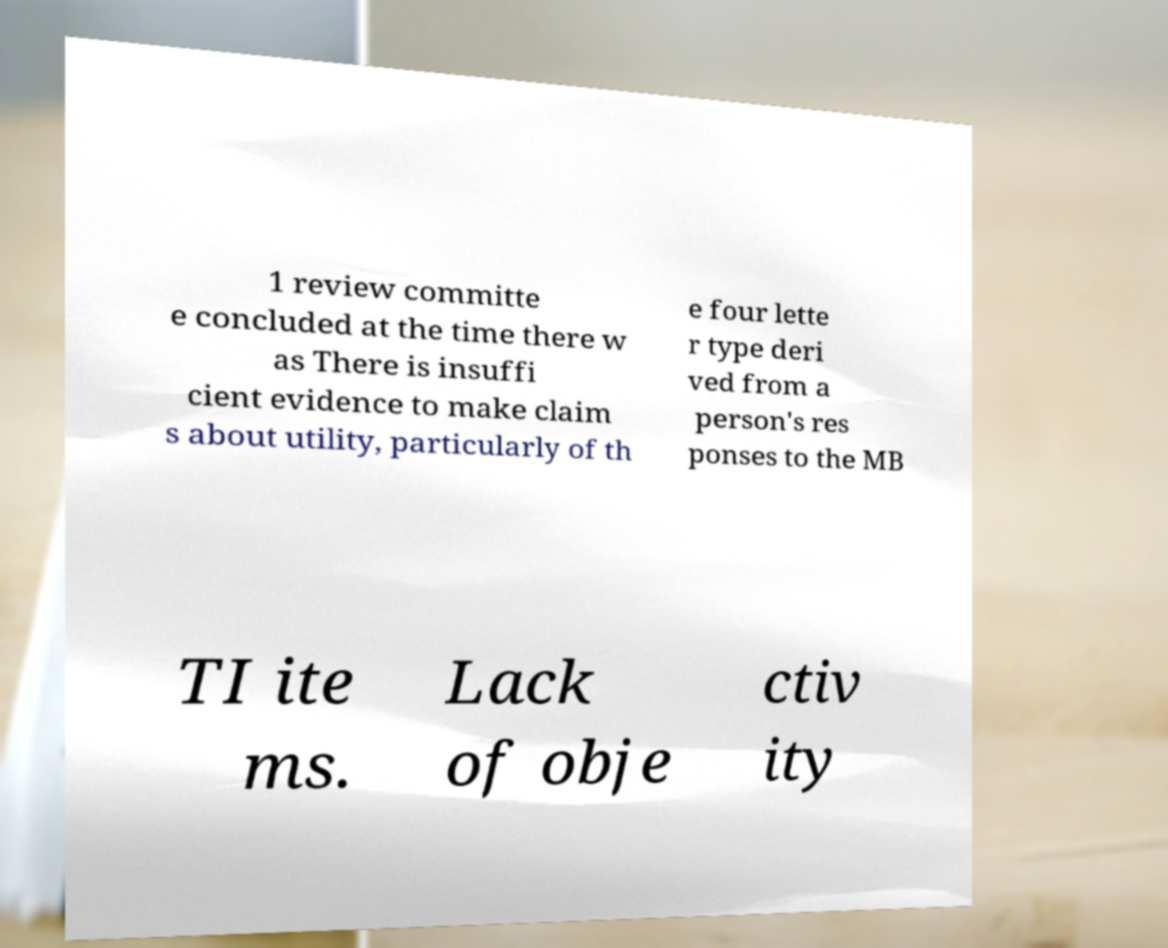Can you read and provide the text displayed in the image?This photo seems to have some interesting text. Can you extract and type it out for me? 1 review committe e concluded at the time there w as There is insuffi cient evidence to make claim s about utility, particularly of th e four lette r type deri ved from a person's res ponses to the MB TI ite ms. Lack of obje ctiv ity 